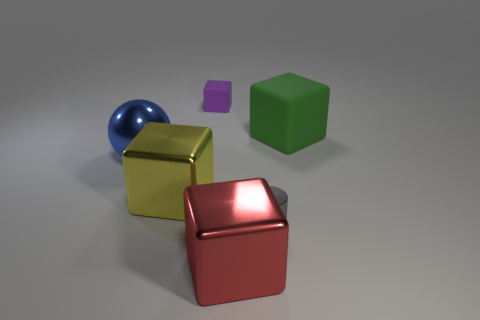What materials do the objects look like they are made of? The materials depicted in the image suggest a variety of textures: the sphere appears to be metallic with a reflective surface, perhaps steel or aluminum, while the cubes exhibit matte surfaces, resembling painted wood or plastic. 